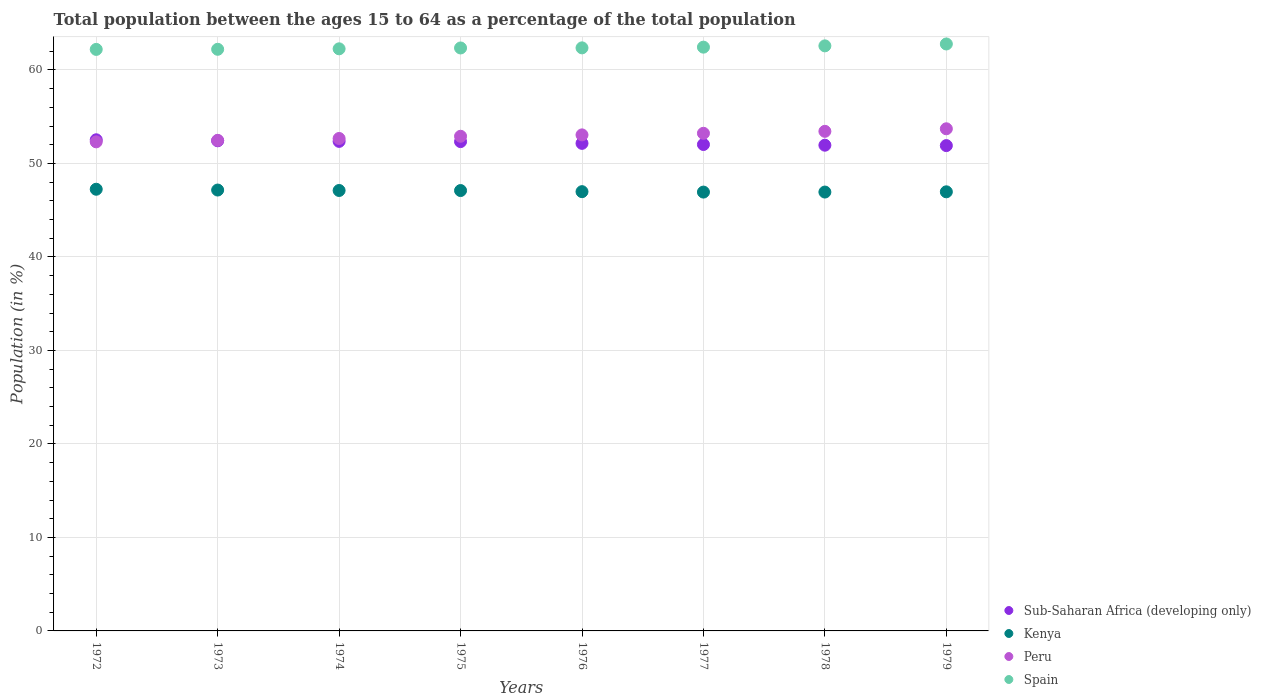What is the percentage of the population ages 15 to 64 in Sub-Saharan Africa (developing only) in 1975?
Keep it short and to the point. 52.34. Across all years, what is the maximum percentage of the population ages 15 to 64 in Kenya?
Your answer should be very brief. 47.24. Across all years, what is the minimum percentage of the population ages 15 to 64 in Peru?
Offer a terse response. 52.31. In which year was the percentage of the population ages 15 to 64 in Sub-Saharan Africa (developing only) minimum?
Your answer should be compact. 1979. What is the total percentage of the population ages 15 to 64 in Peru in the graph?
Keep it short and to the point. 423.77. What is the difference between the percentage of the population ages 15 to 64 in Kenya in 1974 and that in 1977?
Keep it short and to the point. 0.17. What is the difference between the percentage of the population ages 15 to 64 in Kenya in 1979 and the percentage of the population ages 15 to 64 in Spain in 1978?
Provide a short and direct response. -15.61. What is the average percentage of the population ages 15 to 64 in Spain per year?
Your answer should be compact. 62.4. In the year 1973, what is the difference between the percentage of the population ages 15 to 64 in Kenya and percentage of the population ages 15 to 64 in Spain?
Your response must be concise. -15.05. In how many years, is the percentage of the population ages 15 to 64 in Spain greater than 46?
Your response must be concise. 8. What is the ratio of the percentage of the population ages 15 to 64 in Kenya in 1973 to that in 1976?
Provide a short and direct response. 1. Is the difference between the percentage of the population ages 15 to 64 in Kenya in 1974 and 1978 greater than the difference between the percentage of the population ages 15 to 64 in Spain in 1974 and 1978?
Your answer should be very brief. Yes. What is the difference between the highest and the second highest percentage of the population ages 15 to 64 in Kenya?
Offer a terse response. 0.09. What is the difference between the highest and the lowest percentage of the population ages 15 to 64 in Sub-Saharan Africa (developing only)?
Your answer should be compact. 0.62. In how many years, is the percentage of the population ages 15 to 64 in Peru greater than the average percentage of the population ages 15 to 64 in Peru taken over all years?
Provide a short and direct response. 4. Is it the case that in every year, the sum of the percentage of the population ages 15 to 64 in Spain and percentage of the population ages 15 to 64 in Sub-Saharan Africa (developing only)  is greater than the percentage of the population ages 15 to 64 in Kenya?
Keep it short and to the point. Yes. What is the difference between two consecutive major ticks on the Y-axis?
Offer a terse response. 10. Are the values on the major ticks of Y-axis written in scientific E-notation?
Give a very brief answer. No. Does the graph contain any zero values?
Your answer should be very brief. No. Does the graph contain grids?
Ensure brevity in your answer.  Yes. Where does the legend appear in the graph?
Your answer should be compact. Bottom right. How are the legend labels stacked?
Your response must be concise. Vertical. What is the title of the graph?
Ensure brevity in your answer.  Total population between the ages 15 to 64 as a percentage of the total population. Does "Ghana" appear as one of the legend labels in the graph?
Keep it short and to the point. No. What is the Population (in %) in Sub-Saharan Africa (developing only) in 1972?
Provide a short and direct response. 52.53. What is the Population (in %) of Kenya in 1972?
Make the answer very short. 47.24. What is the Population (in %) in Peru in 1972?
Keep it short and to the point. 52.31. What is the Population (in %) in Spain in 1972?
Ensure brevity in your answer.  62.2. What is the Population (in %) in Sub-Saharan Africa (developing only) in 1973?
Your answer should be compact. 52.42. What is the Population (in %) of Kenya in 1973?
Your answer should be compact. 47.15. What is the Population (in %) of Peru in 1973?
Offer a terse response. 52.47. What is the Population (in %) of Spain in 1973?
Make the answer very short. 62.21. What is the Population (in %) in Sub-Saharan Africa (developing only) in 1974?
Give a very brief answer. 52.36. What is the Population (in %) in Kenya in 1974?
Keep it short and to the point. 47.11. What is the Population (in %) of Peru in 1974?
Give a very brief answer. 52.67. What is the Population (in %) in Spain in 1974?
Provide a short and direct response. 62.26. What is the Population (in %) of Sub-Saharan Africa (developing only) in 1975?
Offer a terse response. 52.34. What is the Population (in %) in Kenya in 1975?
Your answer should be very brief. 47.1. What is the Population (in %) of Peru in 1975?
Ensure brevity in your answer.  52.91. What is the Population (in %) of Spain in 1975?
Your response must be concise. 62.35. What is the Population (in %) of Sub-Saharan Africa (developing only) in 1976?
Offer a terse response. 52.15. What is the Population (in %) in Kenya in 1976?
Give a very brief answer. 46.98. What is the Population (in %) of Peru in 1976?
Your answer should be compact. 53.05. What is the Population (in %) in Spain in 1976?
Give a very brief answer. 62.36. What is the Population (in %) in Sub-Saharan Africa (developing only) in 1977?
Make the answer very short. 52.03. What is the Population (in %) of Kenya in 1977?
Your answer should be very brief. 46.94. What is the Population (in %) in Peru in 1977?
Provide a succinct answer. 53.22. What is the Population (in %) of Spain in 1977?
Provide a succinct answer. 62.44. What is the Population (in %) of Sub-Saharan Africa (developing only) in 1978?
Your answer should be very brief. 51.95. What is the Population (in %) in Kenya in 1978?
Provide a short and direct response. 46.94. What is the Population (in %) of Peru in 1978?
Provide a succinct answer. 53.43. What is the Population (in %) in Spain in 1978?
Give a very brief answer. 62.58. What is the Population (in %) of Sub-Saharan Africa (developing only) in 1979?
Give a very brief answer. 51.91. What is the Population (in %) in Kenya in 1979?
Provide a succinct answer. 46.97. What is the Population (in %) in Peru in 1979?
Offer a terse response. 53.71. What is the Population (in %) in Spain in 1979?
Give a very brief answer. 62.78. Across all years, what is the maximum Population (in %) of Sub-Saharan Africa (developing only)?
Ensure brevity in your answer.  52.53. Across all years, what is the maximum Population (in %) of Kenya?
Ensure brevity in your answer.  47.24. Across all years, what is the maximum Population (in %) in Peru?
Offer a terse response. 53.71. Across all years, what is the maximum Population (in %) of Spain?
Give a very brief answer. 62.78. Across all years, what is the minimum Population (in %) in Sub-Saharan Africa (developing only)?
Make the answer very short. 51.91. Across all years, what is the minimum Population (in %) in Kenya?
Ensure brevity in your answer.  46.94. Across all years, what is the minimum Population (in %) of Peru?
Provide a succinct answer. 52.31. Across all years, what is the minimum Population (in %) in Spain?
Your response must be concise. 62.2. What is the total Population (in %) in Sub-Saharan Africa (developing only) in the graph?
Your response must be concise. 417.68. What is the total Population (in %) of Kenya in the graph?
Your response must be concise. 376.42. What is the total Population (in %) in Peru in the graph?
Your response must be concise. 423.77. What is the total Population (in %) in Spain in the graph?
Provide a succinct answer. 499.17. What is the difference between the Population (in %) in Sub-Saharan Africa (developing only) in 1972 and that in 1973?
Provide a short and direct response. 0.11. What is the difference between the Population (in %) of Kenya in 1972 and that in 1973?
Offer a terse response. 0.09. What is the difference between the Population (in %) of Peru in 1972 and that in 1973?
Provide a short and direct response. -0.16. What is the difference between the Population (in %) in Spain in 1972 and that in 1973?
Provide a short and direct response. -0.01. What is the difference between the Population (in %) of Sub-Saharan Africa (developing only) in 1972 and that in 1974?
Offer a terse response. 0.17. What is the difference between the Population (in %) of Kenya in 1972 and that in 1974?
Keep it short and to the point. 0.13. What is the difference between the Population (in %) in Peru in 1972 and that in 1974?
Ensure brevity in your answer.  -0.36. What is the difference between the Population (in %) of Spain in 1972 and that in 1974?
Keep it short and to the point. -0.06. What is the difference between the Population (in %) of Sub-Saharan Africa (developing only) in 1972 and that in 1975?
Make the answer very short. 0.19. What is the difference between the Population (in %) of Kenya in 1972 and that in 1975?
Your response must be concise. 0.14. What is the difference between the Population (in %) in Peru in 1972 and that in 1975?
Ensure brevity in your answer.  -0.6. What is the difference between the Population (in %) of Spain in 1972 and that in 1975?
Offer a very short reply. -0.15. What is the difference between the Population (in %) in Sub-Saharan Africa (developing only) in 1972 and that in 1976?
Your answer should be very brief. 0.38. What is the difference between the Population (in %) of Kenya in 1972 and that in 1976?
Offer a terse response. 0.26. What is the difference between the Population (in %) in Peru in 1972 and that in 1976?
Ensure brevity in your answer.  -0.74. What is the difference between the Population (in %) of Spain in 1972 and that in 1976?
Your answer should be compact. -0.16. What is the difference between the Population (in %) of Sub-Saharan Africa (developing only) in 1972 and that in 1977?
Offer a terse response. 0.5. What is the difference between the Population (in %) of Kenya in 1972 and that in 1977?
Keep it short and to the point. 0.3. What is the difference between the Population (in %) of Peru in 1972 and that in 1977?
Your response must be concise. -0.92. What is the difference between the Population (in %) in Spain in 1972 and that in 1977?
Give a very brief answer. -0.24. What is the difference between the Population (in %) of Sub-Saharan Africa (developing only) in 1972 and that in 1978?
Keep it short and to the point. 0.58. What is the difference between the Population (in %) in Kenya in 1972 and that in 1978?
Keep it short and to the point. 0.3. What is the difference between the Population (in %) of Peru in 1972 and that in 1978?
Your answer should be very brief. -1.12. What is the difference between the Population (in %) in Spain in 1972 and that in 1978?
Your answer should be very brief. -0.38. What is the difference between the Population (in %) of Sub-Saharan Africa (developing only) in 1972 and that in 1979?
Ensure brevity in your answer.  0.62. What is the difference between the Population (in %) in Kenya in 1972 and that in 1979?
Your response must be concise. 0.27. What is the difference between the Population (in %) of Peru in 1972 and that in 1979?
Provide a short and direct response. -1.4. What is the difference between the Population (in %) in Spain in 1972 and that in 1979?
Offer a very short reply. -0.58. What is the difference between the Population (in %) in Sub-Saharan Africa (developing only) in 1973 and that in 1974?
Your answer should be compact. 0.06. What is the difference between the Population (in %) of Kenya in 1973 and that in 1974?
Make the answer very short. 0.05. What is the difference between the Population (in %) of Peru in 1973 and that in 1974?
Keep it short and to the point. -0.2. What is the difference between the Population (in %) in Spain in 1973 and that in 1974?
Ensure brevity in your answer.  -0.05. What is the difference between the Population (in %) of Sub-Saharan Africa (developing only) in 1973 and that in 1975?
Ensure brevity in your answer.  0.09. What is the difference between the Population (in %) in Kenya in 1973 and that in 1975?
Your answer should be compact. 0.05. What is the difference between the Population (in %) of Peru in 1973 and that in 1975?
Provide a short and direct response. -0.44. What is the difference between the Population (in %) in Spain in 1973 and that in 1975?
Ensure brevity in your answer.  -0.14. What is the difference between the Population (in %) in Sub-Saharan Africa (developing only) in 1973 and that in 1976?
Ensure brevity in your answer.  0.28. What is the difference between the Population (in %) of Kenya in 1973 and that in 1976?
Provide a short and direct response. 0.17. What is the difference between the Population (in %) of Peru in 1973 and that in 1976?
Give a very brief answer. -0.58. What is the difference between the Population (in %) in Spain in 1973 and that in 1976?
Provide a succinct answer. -0.15. What is the difference between the Population (in %) of Sub-Saharan Africa (developing only) in 1973 and that in 1977?
Your answer should be compact. 0.4. What is the difference between the Population (in %) of Kenya in 1973 and that in 1977?
Make the answer very short. 0.22. What is the difference between the Population (in %) of Peru in 1973 and that in 1977?
Give a very brief answer. -0.76. What is the difference between the Population (in %) in Spain in 1973 and that in 1977?
Provide a succinct answer. -0.23. What is the difference between the Population (in %) in Sub-Saharan Africa (developing only) in 1973 and that in 1978?
Your answer should be very brief. 0.47. What is the difference between the Population (in %) in Kenya in 1973 and that in 1978?
Keep it short and to the point. 0.22. What is the difference between the Population (in %) in Peru in 1973 and that in 1978?
Offer a very short reply. -0.96. What is the difference between the Population (in %) in Spain in 1973 and that in 1978?
Provide a succinct answer. -0.37. What is the difference between the Population (in %) of Sub-Saharan Africa (developing only) in 1973 and that in 1979?
Keep it short and to the point. 0.51. What is the difference between the Population (in %) of Kenya in 1973 and that in 1979?
Give a very brief answer. 0.19. What is the difference between the Population (in %) of Peru in 1973 and that in 1979?
Your response must be concise. -1.24. What is the difference between the Population (in %) in Spain in 1973 and that in 1979?
Your answer should be very brief. -0.57. What is the difference between the Population (in %) of Sub-Saharan Africa (developing only) in 1974 and that in 1975?
Provide a short and direct response. 0.02. What is the difference between the Population (in %) in Kenya in 1974 and that in 1975?
Offer a very short reply. 0.01. What is the difference between the Population (in %) of Peru in 1974 and that in 1975?
Make the answer very short. -0.24. What is the difference between the Population (in %) of Spain in 1974 and that in 1975?
Ensure brevity in your answer.  -0.09. What is the difference between the Population (in %) in Sub-Saharan Africa (developing only) in 1974 and that in 1976?
Make the answer very short. 0.21. What is the difference between the Population (in %) in Kenya in 1974 and that in 1976?
Offer a terse response. 0.13. What is the difference between the Population (in %) of Peru in 1974 and that in 1976?
Provide a succinct answer. -0.38. What is the difference between the Population (in %) in Spain in 1974 and that in 1976?
Make the answer very short. -0.1. What is the difference between the Population (in %) in Sub-Saharan Africa (developing only) in 1974 and that in 1977?
Keep it short and to the point. 0.33. What is the difference between the Population (in %) of Kenya in 1974 and that in 1977?
Provide a succinct answer. 0.17. What is the difference between the Population (in %) in Peru in 1974 and that in 1977?
Offer a very short reply. -0.55. What is the difference between the Population (in %) in Spain in 1974 and that in 1977?
Offer a terse response. -0.18. What is the difference between the Population (in %) of Sub-Saharan Africa (developing only) in 1974 and that in 1978?
Keep it short and to the point. 0.41. What is the difference between the Population (in %) in Kenya in 1974 and that in 1978?
Ensure brevity in your answer.  0.17. What is the difference between the Population (in %) of Peru in 1974 and that in 1978?
Keep it short and to the point. -0.76. What is the difference between the Population (in %) of Spain in 1974 and that in 1978?
Give a very brief answer. -0.32. What is the difference between the Population (in %) of Sub-Saharan Africa (developing only) in 1974 and that in 1979?
Your answer should be very brief. 0.45. What is the difference between the Population (in %) of Kenya in 1974 and that in 1979?
Your answer should be compact. 0.14. What is the difference between the Population (in %) of Peru in 1974 and that in 1979?
Provide a succinct answer. -1.04. What is the difference between the Population (in %) of Spain in 1974 and that in 1979?
Give a very brief answer. -0.52. What is the difference between the Population (in %) in Sub-Saharan Africa (developing only) in 1975 and that in 1976?
Offer a terse response. 0.19. What is the difference between the Population (in %) of Kenya in 1975 and that in 1976?
Offer a very short reply. 0.12. What is the difference between the Population (in %) in Peru in 1975 and that in 1976?
Your response must be concise. -0.15. What is the difference between the Population (in %) in Spain in 1975 and that in 1976?
Give a very brief answer. -0.01. What is the difference between the Population (in %) of Sub-Saharan Africa (developing only) in 1975 and that in 1977?
Your answer should be compact. 0.31. What is the difference between the Population (in %) of Kenya in 1975 and that in 1977?
Make the answer very short. 0.16. What is the difference between the Population (in %) of Peru in 1975 and that in 1977?
Your response must be concise. -0.32. What is the difference between the Population (in %) of Spain in 1975 and that in 1977?
Make the answer very short. -0.09. What is the difference between the Population (in %) of Sub-Saharan Africa (developing only) in 1975 and that in 1978?
Keep it short and to the point. 0.38. What is the difference between the Population (in %) of Kenya in 1975 and that in 1978?
Make the answer very short. 0.16. What is the difference between the Population (in %) of Peru in 1975 and that in 1978?
Provide a short and direct response. -0.53. What is the difference between the Population (in %) in Spain in 1975 and that in 1978?
Your answer should be compact. -0.23. What is the difference between the Population (in %) in Sub-Saharan Africa (developing only) in 1975 and that in 1979?
Keep it short and to the point. 0.43. What is the difference between the Population (in %) in Kenya in 1975 and that in 1979?
Your answer should be compact. 0.14. What is the difference between the Population (in %) in Peru in 1975 and that in 1979?
Your answer should be very brief. -0.8. What is the difference between the Population (in %) of Spain in 1975 and that in 1979?
Give a very brief answer. -0.43. What is the difference between the Population (in %) in Sub-Saharan Africa (developing only) in 1976 and that in 1977?
Offer a terse response. 0.12. What is the difference between the Population (in %) in Kenya in 1976 and that in 1977?
Offer a terse response. 0.05. What is the difference between the Population (in %) of Peru in 1976 and that in 1977?
Provide a succinct answer. -0.17. What is the difference between the Population (in %) of Spain in 1976 and that in 1977?
Provide a succinct answer. -0.08. What is the difference between the Population (in %) of Sub-Saharan Africa (developing only) in 1976 and that in 1978?
Keep it short and to the point. 0.2. What is the difference between the Population (in %) of Kenya in 1976 and that in 1978?
Your response must be concise. 0.04. What is the difference between the Population (in %) in Peru in 1976 and that in 1978?
Ensure brevity in your answer.  -0.38. What is the difference between the Population (in %) in Spain in 1976 and that in 1978?
Ensure brevity in your answer.  -0.21. What is the difference between the Population (in %) of Sub-Saharan Africa (developing only) in 1976 and that in 1979?
Your answer should be very brief. 0.24. What is the difference between the Population (in %) in Kenya in 1976 and that in 1979?
Provide a short and direct response. 0.02. What is the difference between the Population (in %) of Peru in 1976 and that in 1979?
Ensure brevity in your answer.  -0.65. What is the difference between the Population (in %) in Spain in 1976 and that in 1979?
Offer a very short reply. -0.42. What is the difference between the Population (in %) of Sub-Saharan Africa (developing only) in 1977 and that in 1978?
Ensure brevity in your answer.  0.07. What is the difference between the Population (in %) of Kenya in 1977 and that in 1978?
Offer a very short reply. -0. What is the difference between the Population (in %) of Peru in 1977 and that in 1978?
Provide a short and direct response. -0.21. What is the difference between the Population (in %) of Spain in 1977 and that in 1978?
Keep it short and to the point. -0.14. What is the difference between the Population (in %) in Sub-Saharan Africa (developing only) in 1977 and that in 1979?
Offer a terse response. 0.12. What is the difference between the Population (in %) in Kenya in 1977 and that in 1979?
Keep it short and to the point. -0.03. What is the difference between the Population (in %) of Peru in 1977 and that in 1979?
Give a very brief answer. -0.48. What is the difference between the Population (in %) in Spain in 1977 and that in 1979?
Ensure brevity in your answer.  -0.34. What is the difference between the Population (in %) of Sub-Saharan Africa (developing only) in 1978 and that in 1979?
Ensure brevity in your answer.  0.04. What is the difference between the Population (in %) of Kenya in 1978 and that in 1979?
Give a very brief answer. -0.03. What is the difference between the Population (in %) in Peru in 1978 and that in 1979?
Your response must be concise. -0.27. What is the difference between the Population (in %) in Spain in 1978 and that in 1979?
Your answer should be compact. -0.2. What is the difference between the Population (in %) in Sub-Saharan Africa (developing only) in 1972 and the Population (in %) in Kenya in 1973?
Give a very brief answer. 5.38. What is the difference between the Population (in %) in Sub-Saharan Africa (developing only) in 1972 and the Population (in %) in Peru in 1973?
Provide a short and direct response. 0.06. What is the difference between the Population (in %) of Sub-Saharan Africa (developing only) in 1972 and the Population (in %) of Spain in 1973?
Your answer should be very brief. -9.68. What is the difference between the Population (in %) of Kenya in 1972 and the Population (in %) of Peru in 1973?
Provide a succinct answer. -5.23. What is the difference between the Population (in %) of Kenya in 1972 and the Population (in %) of Spain in 1973?
Offer a very short reply. -14.97. What is the difference between the Population (in %) in Peru in 1972 and the Population (in %) in Spain in 1973?
Your response must be concise. -9.9. What is the difference between the Population (in %) in Sub-Saharan Africa (developing only) in 1972 and the Population (in %) in Kenya in 1974?
Make the answer very short. 5.42. What is the difference between the Population (in %) in Sub-Saharan Africa (developing only) in 1972 and the Population (in %) in Peru in 1974?
Your response must be concise. -0.14. What is the difference between the Population (in %) in Sub-Saharan Africa (developing only) in 1972 and the Population (in %) in Spain in 1974?
Provide a short and direct response. -9.73. What is the difference between the Population (in %) of Kenya in 1972 and the Population (in %) of Peru in 1974?
Make the answer very short. -5.43. What is the difference between the Population (in %) of Kenya in 1972 and the Population (in %) of Spain in 1974?
Your answer should be very brief. -15.02. What is the difference between the Population (in %) in Peru in 1972 and the Population (in %) in Spain in 1974?
Keep it short and to the point. -9.95. What is the difference between the Population (in %) of Sub-Saharan Africa (developing only) in 1972 and the Population (in %) of Kenya in 1975?
Your response must be concise. 5.43. What is the difference between the Population (in %) of Sub-Saharan Africa (developing only) in 1972 and the Population (in %) of Peru in 1975?
Offer a very short reply. -0.38. What is the difference between the Population (in %) of Sub-Saharan Africa (developing only) in 1972 and the Population (in %) of Spain in 1975?
Offer a very short reply. -9.82. What is the difference between the Population (in %) of Kenya in 1972 and the Population (in %) of Peru in 1975?
Make the answer very short. -5.67. What is the difference between the Population (in %) of Kenya in 1972 and the Population (in %) of Spain in 1975?
Keep it short and to the point. -15.11. What is the difference between the Population (in %) of Peru in 1972 and the Population (in %) of Spain in 1975?
Your answer should be compact. -10.04. What is the difference between the Population (in %) in Sub-Saharan Africa (developing only) in 1972 and the Population (in %) in Kenya in 1976?
Keep it short and to the point. 5.55. What is the difference between the Population (in %) of Sub-Saharan Africa (developing only) in 1972 and the Population (in %) of Peru in 1976?
Offer a very short reply. -0.52. What is the difference between the Population (in %) of Sub-Saharan Africa (developing only) in 1972 and the Population (in %) of Spain in 1976?
Offer a very short reply. -9.83. What is the difference between the Population (in %) of Kenya in 1972 and the Population (in %) of Peru in 1976?
Your answer should be very brief. -5.81. What is the difference between the Population (in %) in Kenya in 1972 and the Population (in %) in Spain in 1976?
Provide a succinct answer. -15.12. What is the difference between the Population (in %) in Peru in 1972 and the Population (in %) in Spain in 1976?
Give a very brief answer. -10.05. What is the difference between the Population (in %) of Sub-Saharan Africa (developing only) in 1972 and the Population (in %) of Kenya in 1977?
Ensure brevity in your answer.  5.59. What is the difference between the Population (in %) in Sub-Saharan Africa (developing only) in 1972 and the Population (in %) in Peru in 1977?
Offer a very short reply. -0.69. What is the difference between the Population (in %) of Sub-Saharan Africa (developing only) in 1972 and the Population (in %) of Spain in 1977?
Offer a terse response. -9.91. What is the difference between the Population (in %) of Kenya in 1972 and the Population (in %) of Peru in 1977?
Offer a very short reply. -5.99. What is the difference between the Population (in %) of Kenya in 1972 and the Population (in %) of Spain in 1977?
Make the answer very short. -15.2. What is the difference between the Population (in %) of Peru in 1972 and the Population (in %) of Spain in 1977?
Give a very brief answer. -10.13. What is the difference between the Population (in %) of Sub-Saharan Africa (developing only) in 1972 and the Population (in %) of Kenya in 1978?
Provide a short and direct response. 5.59. What is the difference between the Population (in %) of Sub-Saharan Africa (developing only) in 1972 and the Population (in %) of Peru in 1978?
Provide a short and direct response. -0.9. What is the difference between the Population (in %) in Sub-Saharan Africa (developing only) in 1972 and the Population (in %) in Spain in 1978?
Ensure brevity in your answer.  -10.05. What is the difference between the Population (in %) of Kenya in 1972 and the Population (in %) of Peru in 1978?
Give a very brief answer. -6.19. What is the difference between the Population (in %) of Kenya in 1972 and the Population (in %) of Spain in 1978?
Your response must be concise. -15.34. What is the difference between the Population (in %) in Peru in 1972 and the Population (in %) in Spain in 1978?
Offer a very short reply. -10.27. What is the difference between the Population (in %) of Sub-Saharan Africa (developing only) in 1972 and the Population (in %) of Kenya in 1979?
Provide a succinct answer. 5.56. What is the difference between the Population (in %) in Sub-Saharan Africa (developing only) in 1972 and the Population (in %) in Peru in 1979?
Your answer should be very brief. -1.18. What is the difference between the Population (in %) in Sub-Saharan Africa (developing only) in 1972 and the Population (in %) in Spain in 1979?
Give a very brief answer. -10.25. What is the difference between the Population (in %) in Kenya in 1972 and the Population (in %) in Peru in 1979?
Your answer should be very brief. -6.47. What is the difference between the Population (in %) in Kenya in 1972 and the Population (in %) in Spain in 1979?
Your response must be concise. -15.54. What is the difference between the Population (in %) in Peru in 1972 and the Population (in %) in Spain in 1979?
Offer a very short reply. -10.47. What is the difference between the Population (in %) of Sub-Saharan Africa (developing only) in 1973 and the Population (in %) of Kenya in 1974?
Your response must be concise. 5.31. What is the difference between the Population (in %) of Sub-Saharan Africa (developing only) in 1973 and the Population (in %) of Peru in 1974?
Provide a succinct answer. -0.25. What is the difference between the Population (in %) in Sub-Saharan Africa (developing only) in 1973 and the Population (in %) in Spain in 1974?
Your answer should be compact. -9.84. What is the difference between the Population (in %) in Kenya in 1973 and the Population (in %) in Peru in 1974?
Offer a terse response. -5.52. What is the difference between the Population (in %) in Kenya in 1973 and the Population (in %) in Spain in 1974?
Your answer should be compact. -15.11. What is the difference between the Population (in %) of Peru in 1973 and the Population (in %) of Spain in 1974?
Your answer should be very brief. -9.79. What is the difference between the Population (in %) in Sub-Saharan Africa (developing only) in 1973 and the Population (in %) in Kenya in 1975?
Provide a short and direct response. 5.32. What is the difference between the Population (in %) of Sub-Saharan Africa (developing only) in 1973 and the Population (in %) of Peru in 1975?
Your response must be concise. -0.48. What is the difference between the Population (in %) of Sub-Saharan Africa (developing only) in 1973 and the Population (in %) of Spain in 1975?
Give a very brief answer. -9.93. What is the difference between the Population (in %) in Kenya in 1973 and the Population (in %) in Peru in 1975?
Offer a terse response. -5.75. What is the difference between the Population (in %) in Kenya in 1973 and the Population (in %) in Spain in 1975?
Give a very brief answer. -15.2. What is the difference between the Population (in %) of Peru in 1973 and the Population (in %) of Spain in 1975?
Make the answer very short. -9.88. What is the difference between the Population (in %) in Sub-Saharan Africa (developing only) in 1973 and the Population (in %) in Kenya in 1976?
Give a very brief answer. 5.44. What is the difference between the Population (in %) in Sub-Saharan Africa (developing only) in 1973 and the Population (in %) in Peru in 1976?
Your response must be concise. -0.63. What is the difference between the Population (in %) in Sub-Saharan Africa (developing only) in 1973 and the Population (in %) in Spain in 1976?
Offer a very short reply. -9.94. What is the difference between the Population (in %) of Kenya in 1973 and the Population (in %) of Peru in 1976?
Offer a terse response. -5.9. What is the difference between the Population (in %) of Kenya in 1973 and the Population (in %) of Spain in 1976?
Keep it short and to the point. -15.21. What is the difference between the Population (in %) of Peru in 1973 and the Population (in %) of Spain in 1976?
Your answer should be very brief. -9.89. What is the difference between the Population (in %) in Sub-Saharan Africa (developing only) in 1973 and the Population (in %) in Kenya in 1977?
Your response must be concise. 5.49. What is the difference between the Population (in %) in Sub-Saharan Africa (developing only) in 1973 and the Population (in %) in Peru in 1977?
Offer a very short reply. -0.8. What is the difference between the Population (in %) of Sub-Saharan Africa (developing only) in 1973 and the Population (in %) of Spain in 1977?
Offer a terse response. -10.02. What is the difference between the Population (in %) in Kenya in 1973 and the Population (in %) in Peru in 1977?
Your answer should be very brief. -6.07. What is the difference between the Population (in %) in Kenya in 1973 and the Population (in %) in Spain in 1977?
Provide a succinct answer. -15.28. What is the difference between the Population (in %) in Peru in 1973 and the Population (in %) in Spain in 1977?
Offer a very short reply. -9.97. What is the difference between the Population (in %) of Sub-Saharan Africa (developing only) in 1973 and the Population (in %) of Kenya in 1978?
Your answer should be compact. 5.48. What is the difference between the Population (in %) of Sub-Saharan Africa (developing only) in 1973 and the Population (in %) of Peru in 1978?
Ensure brevity in your answer.  -1.01. What is the difference between the Population (in %) of Sub-Saharan Africa (developing only) in 1973 and the Population (in %) of Spain in 1978?
Offer a very short reply. -10.15. What is the difference between the Population (in %) of Kenya in 1973 and the Population (in %) of Peru in 1978?
Offer a very short reply. -6.28. What is the difference between the Population (in %) of Kenya in 1973 and the Population (in %) of Spain in 1978?
Your response must be concise. -15.42. What is the difference between the Population (in %) of Peru in 1973 and the Population (in %) of Spain in 1978?
Provide a succinct answer. -10.11. What is the difference between the Population (in %) of Sub-Saharan Africa (developing only) in 1973 and the Population (in %) of Kenya in 1979?
Offer a terse response. 5.46. What is the difference between the Population (in %) in Sub-Saharan Africa (developing only) in 1973 and the Population (in %) in Peru in 1979?
Keep it short and to the point. -1.28. What is the difference between the Population (in %) in Sub-Saharan Africa (developing only) in 1973 and the Population (in %) in Spain in 1979?
Keep it short and to the point. -10.35. What is the difference between the Population (in %) in Kenya in 1973 and the Population (in %) in Peru in 1979?
Offer a terse response. -6.55. What is the difference between the Population (in %) in Kenya in 1973 and the Population (in %) in Spain in 1979?
Give a very brief answer. -15.62. What is the difference between the Population (in %) of Peru in 1973 and the Population (in %) of Spain in 1979?
Keep it short and to the point. -10.31. What is the difference between the Population (in %) of Sub-Saharan Africa (developing only) in 1974 and the Population (in %) of Kenya in 1975?
Keep it short and to the point. 5.26. What is the difference between the Population (in %) in Sub-Saharan Africa (developing only) in 1974 and the Population (in %) in Peru in 1975?
Your response must be concise. -0.55. What is the difference between the Population (in %) in Sub-Saharan Africa (developing only) in 1974 and the Population (in %) in Spain in 1975?
Ensure brevity in your answer.  -9.99. What is the difference between the Population (in %) of Kenya in 1974 and the Population (in %) of Peru in 1975?
Your answer should be very brief. -5.8. What is the difference between the Population (in %) in Kenya in 1974 and the Population (in %) in Spain in 1975?
Provide a short and direct response. -15.24. What is the difference between the Population (in %) of Peru in 1974 and the Population (in %) of Spain in 1975?
Your answer should be compact. -9.68. What is the difference between the Population (in %) in Sub-Saharan Africa (developing only) in 1974 and the Population (in %) in Kenya in 1976?
Offer a very short reply. 5.38. What is the difference between the Population (in %) of Sub-Saharan Africa (developing only) in 1974 and the Population (in %) of Peru in 1976?
Your response must be concise. -0.69. What is the difference between the Population (in %) in Sub-Saharan Africa (developing only) in 1974 and the Population (in %) in Spain in 1976?
Keep it short and to the point. -10. What is the difference between the Population (in %) in Kenya in 1974 and the Population (in %) in Peru in 1976?
Your response must be concise. -5.95. What is the difference between the Population (in %) of Kenya in 1974 and the Population (in %) of Spain in 1976?
Keep it short and to the point. -15.25. What is the difference between the Population (in %) in Peru in 1974 and the Population (in %) in Spain in 1976?
Ensure brevity in your answer.  -9.69. What is the difference between the Population (in %) in Sub-Saharan Africa (developing only) in 1974 and the Population (in %) in Kenya in 1977?
Keep it short and to the point. 5.42. What is the difference between the Population (in %) in Sub-Saharan Africa (developing only) in 1974 and the Population (in %) in Peru in 1977?
Offer a very short reply. -0.87. What is the difference between the Population (in %) of Sub-Saharan Africa (developing only) in 1974 and the Population (in %) of Spain in 1977?
Your answer should be compact. -10.08. What is the difference between the Population (in %) in Kenya in 1974 and the Population (in %) in Peru in 1977?
Your response must be concise. -6.12. What is the difference between the Population (in %) of Kenya in 1974 and the Population (in %) of Spain in 1977?
Make the answer very short. -15.33. What is the difference between the Population (in %) of Peru in 1974 and the Population (in %) of Spain in 1977?
Give a very brief answer. -9.77. What is the difference between the Population (in %) in Sub-Saharan Africa (developing only) in 1974 and the Population (in %) in Kenya in 1978?
Offer a terse response. 5.42. What is the difference between the Population (in %) in Sub-Saharan Africa (developing only) in 1974 and the Population (in %) in Peru in 1978?
Provide a short and direct response. -1.07. What is the difference between the Population (in %) of Sub-Saharan Africa (developing only) in 1974 and the Population (in %) of Spain in 1978?
Your answer should be very brief. -10.22. What is the difference between the Population (in %) of Kenya in 1974 and the Population (in %) of Peru in 1978?
Your answer should be very brief. -6.33. What is the difference between the Population (in %) in Kenya in 1974 and the Population (in %) in Spain in 1978?
Provide a succinct answer. -15.47. What is the difference between the Population (in %) of Peru in 1974 and the Population (in %) of Spain in 1978?
Provide a short and direct response. -9.91. What is the difference between the Population (in %) in Sub-Saharan Africa (developing only) in 1974 and the Population (in %) in Kenya in 1979?
Your answer should be very brief. 5.39. What is the difference between the Population (in %) of Sub-Saharan Africa (developing only) in 1974 and the Population (in %) of Peru in 1979?
Offer a terse response. -1.35. What is the difference between the Population (in %) of Sub-Saharan Africa (developing only) in 1974 and the Population (in %) of Spain in 1979?
Offer a terse response. -10.42. What is the difference between the Population (in %) of Kenya in 1974 and the Population (in %) of Peru in 1979?
Your answer should be very brief. -6.6. What is the difference between the Population (in %) of Kenya in 1974 and the Population (in %) of Spain in 1979?
Ensure brevity in your answer.  -15.67. What is the difference between the Population (in %) in Peru in 1974 and the Population (in %) in Spain in 1979?
Offer a very short reply. -10.11. What is the difference between the Population (in %) of Sub-Saharan Africa (developing only) in 1975 and the Population (in %) of Kenya in 1976?
Give a very brief answer. 5.35. What is the difference between the Population (in %) in Sub-Saharan Africa (developing only) in 1975 and the Population (in %) in Peru in 1976?
Make the answer very short. -0.72. What is the difference between the Population (in %) of Sub-Saharan Africa (developing only) in 1975 and the Population (in %) of Spain in 1976?
Keep it short and to the point. -10.03. What is the difference between the Population (in %) of Kenya in 1975 and the Population (in %) of Peru in 1976?
Your answer should be very brief. -5.95. What is the difference between the Population (in %) of Kenya in 1975 and the Population (in %) of Spain in 1976?
Provide a succinct answer. -15.26. What is the difference between the Population (in %) in Peru in 1975 and the Population (in %) in Spain in 1976?
Offer a terse response. -9.46. What is the difference between the Population (in %) of Sub-Saharan Africa (developing only) in 1975 and the Population (in %) of Kenya in 1977?
Ensure brevity in your answer.  5.4. What is the difference between the Population (in %) in Sub-Saharan Africa (developing only) in 1975 and the Population (in %) in Peru in 1977?
Your answer should be compact. -0.89. What is the difference between the Population (in %) of Sub-Saharan Africa (developing only) in 1975 and the Population (in %) of Spain in 1977?
Your answer should be compact. -10.1. What is the difference between the Population (in %) of Kenya in 1975 and the Population (in %) of Peru in 1977?
Offer a terse response. -6.12. What is the difference between the Population (in %) in Kenya in 1975 and the Population (in %) in Spain in 1977?
Provide a short and direct response. -15.34. What is the difference between the Population (in %) in Peru in 1975 and the Population (in %) in Spain in 1977?
Give a very brief answer. -9.53. What is the difference between the Population (in %) of Sub-Saharan Africa (developing only) in 1975 and the Population (in %) of Kenya in 1978?
Keep it short and to the point. 5.4. What is the difference between the Population (in %) of Sub-Saharan Africa (developing only) in 1975 and the Population (in %) of Peru in 1978?
Provide a short and direct response. -1.1. What is the difference between the Population (in %) of Sub-Saharan Africa (developing only) in 1975 and the Population (in %) of Spain in 1978?
Offer a very short reply. -10.24. What is the difference between the Population (in %) of Kenya in 1975 and the Population (in %) of Peru in 1978?
Offer a very short reply. -6.33. What is the difference between the Population (in %) of Kenya in 1975 and the Population (in %) of Spain in 1978?
Provide a short and direct response. -15.48. What is the difference between the Population (in %) of Peru in 1975 and the Population (in %) of Spain in 1978?
Your answer should be compact. -9.67. What is the difference between the Population (in %) in Sub-Saharan Africa (developing only) in 1975 and the Population (in %) in Kenya in 1979?
Offer a terse response. 5.37. What is the difference between the Population (in %) in Sub-Saharan Africa (developing only) in 1975 and the Population (in %) in Peru in 1979?
Provide a succinct answer. -1.37. What is the difference between the Population (in %) in Sub-Saharan Africa (developing only) in 1975 and the Population (in %) in Spain in 1979?
Your response must be concise. -10.44. What is the difference between the Population (in %) of Kenya in 1975 and the Population (in %) of Peru in 1979?
Offer a very short reply. -6.61. What is the difference between the Population (in %) of Kenya in 1975 and the Population (in %) of Spain in 1979?
Offer a terse response. -15.68. What is the difference between the Population (in %) of Peru in 1975 and the Population (in %) of Spain in 1979?
Keep it short and to the point. -9.87. What is the difference between the Population (in %) in Sub-Saharan Africa (developing only) in 1976 and the Population (in %) in Kenya in 1977?
Offer a terse response. 5.21. What is the difference between the Population (in %) of Sub-Saharan Africa (developing only) in 1976 and the Population (in %) of Peru in 1977?
Your answer should be very brief. -1.08. What is the difference between the Population (in %) in Sub-Saharan Africa (developing only) in 1976 and the Population (in %) in Spain in 1977?
Ensure brevity in your answer.  -10.29. What is the difference between the Population (in %) of Kenya in 1976 and the Population (in %) of Peru in 1977?
Provide a short and direct response. -6.24. What is the difference between the Population (in %) in Kenya in 1976 and the Population (in %) in Spain in 1977?
Your response must be concise. -15.46. What is the difference between the Population (in %) of Peru in 1976 and the Population (in %) of Spain in 1977?
Make the answer very short. -9.38. What is the difference between the Population (in %) in Sub-Saharan Africa (developing only) in 1976 and the Population (in %) in Kenya in 1978?
Your answer should be compact. 5.21. What is the difference between the Population (in %) of Sub-Saharan Africa (developing only) in 1976 and the Population (in %) of Peru in 1978?
Give a very brief answer. -1.29. What is the difference between the Population (in %) in Sub-Saharan Africa (developing only) in 1976 and the Population (in %) in Spain in 1978?
Keep it short and to the point. -10.43. What is the difference between the Population (in %) in Kenya in 1976 and the Population (in %) in Peru in 1978?
Offer a very short reply. -6.45. What is the difference between the Population (in %) in Kenya in 1976 and the Population (in %) in Spain in 1978?
Provide a succinct answer. -15.59. What is the difference between the Population (in %) of Peru in 1976 and the Population (in %) of Spain in 1978?
Give a very brief answer. -9.52. What is the difference between the Population (in %) in Sub-Saharan Africa (developing only) in 1976 and the Population (in %) in Kenya in 1979?
Ensure brevity in your answer.  5.18. What is the difference between the Population (in %) of Sub-Saharan Africa (developing only) in 1976 and the Population (in %) of Peru in 1979?
Provide a succinct answer. -1.56. What is the difference between the Population (in %) in Sub-Saharan Africa (developing only) in 1976 and the Population (in %) in Spain in 1979?
Provide a short and direct response. -10.63. What is the difference between the Population (in %) in Kenya in 1976 and the Population (in %) in Peru in 1979?
Provide a succinct answer. -6.73. What is the difference between the Population (in %) in Kenya in 1976 and the Population (in %) in Spain in 1979?
Your answer should be very brief. -15.8. What is the difference between the Population (in %) in Peru in 1976 and the Population (in %) in Spain in 1979?
Offer a very short reply. -9.72. What is the difference between the Population (in %) in Sub-Saharan Africa (developing only) in 1977 and the Population (in %) in Kenya in 1978?
Give a very brief answer. 5.09. What is the difference between the Population (in %) in Sub-Saharan Africa (developing only) in 1977 and the Population (in %) in Peru in 1978?
Your answer should be compact. -1.41. What is the difference between the Population (in %) of Sub-Saharan Africa (developing only) in 1977 and the Population (in %) of Spain in 1978?
Your answer should be very brief. -10.55. What is the difference between the Population (in %) in Kenya in 1977 and the Population (in %) in Peru in 1978?
Give a very brief answer. -6.5. What is the difference between the Population (in %) of Kenya in 1977 and the Population (in %) of Spain in 1978?
Your response must be concise. -15.64. What is the difference between the Population (in %) in Peru in 1977 and the Population (in %) in Spain in 1978?
Provide a short and direct response. -9.35. What is the difference between the Population (in %) of Sub-Saharan Africa (developing only) in 1977 and the Population (in %) of Kenya in 1979?
Offer a terse response. 5.06. What is the difference between the Population (in %) of Sub-Saharan Africa (developing only) in 1977 and the Population (in %) of Peru in 1979?
Provide a short and direct response. -1.68. What is the difference between the Population (in %) of Sub-Saharan Africa (developing only) in 1977 and the Population (in %) of Spain in 1979?
Provide a short and direct response. -10.75. What is the difference between the Population (in %) in Kenya in 1977 and the Population (in %) in Peru in 1979?
Your answer should be very brief. -6.77. What is the difference between the Population (in %) in Kenya in 1977 and the Population (in %) in Spain in 1979?
Your answer should be very brief. -15.84. What is the difference between the Population (in %) of Peru in 1977 and the Population (in %) of Spain in 1979?
Keep it short and to the point. -9.55. What is the difference between the Population (in %) of Sub-Saharan Africa (developing only) in 1978 and the Population (in %) of Kenya in 1979?
Provide a short and direct response. 4.99. What is the difference between the Population (in %) in Sub-Saharan Africa (developing only) in 1978 and the Population (in %) in Peru in 1979?
Offer a terse response. -1.76. What is the difference between the Population (in %) of Sub-Saharan Africa (developing only) in 1978 and the Population (in %) of Spain in 1979?
Your response must be concise. -10.83. What is the difference between the Population (in %) in Kenya in 1978 and the Population (in %) in Peru in 1979?
Offer a very short reply. -6.77. What is the difference between the Population (in %) in Kenya in 1978 and the Population (in %) in Spain in 1979?
Your response must be concise. -15.84. What is the difference between the Population (in %) of Peru in 1978 and the Population (in %) of Spain in 1979?
Provide a succinct answer. -9.34. What is the average Population (in %) of Sub-Saharan Africa (developing only) per year?
Provide a succinct answer. 52.21. What is the average Population (in %) of Kenya per year?
Your answer should be compact. 47.05. What is the average Population (in %) of Peru per year?
Your answer should be compact. 52.97. What is the average Population (in %) in Spain per year?
Provide a succinct answer. 62.4. In the year 1972, what is the difference between the Population (in %) of Sub-Saharan Africa (developing only) and Population (in %) of Kenya?
Your response must be concise. 5.29. In the year 1972, what is the difference between the Population (in %) in Sub-Saharan Africa (developing only) and Population (in %) in Peru?
Make the answer very short. 0.22. In the year 1972, what is the difference between the Population (in %) of Sub-Saharan Africa (developing only) and Population (in %) of Spain?
Offer a terse response. -9.67. In the year 1972, what is the difference between the Population (in %) in Kenya and Population (in %) in Peru?
Provide a succinct answer. -5.07. In the year 1972, what is the difference between the Population (in %) in Kenya and Population (in %) in Spain?
Make the answer very short. -14.96. In the year 1972, what is the difference between the Population (in %) in Peru and Population (in %) in Spain?
Your response must be concise. -9.89. In the year 1973, what is the difference between the Population (in %) of Sub-Saharan Africa (developing only) and Population (in %) of Kenya?
Offer a terse response. 5.27. In the year 1973, what is the difference between the Population (in %) of Sub-Saharan Africa (developing only) and Population (in %) of Peru?
Provide a succinct answer. -0.05. In the year 1973, what is the difference between the Population (in %) of Sub-Saharan Africa (developing only) and Population (in %) of Spain?
Ensure brevity in your answer.  -9.79. In the year 1973, what is the difference between the Population (in %) in Kenya and Population (in %) in Peru?
Keep it short and to the point. -5.31. In the year 1973, what is the difference between the Population (in %) in Kenya and Population (in %) in Spain?
Ensure brevity in your answer.  -15.05. In the year 1973, what is the difference between the Population (in %) of Peru and Population (in %) of Spain?
Provide a succinct answer. -9.74. In the year 1974, what is the difference between the Population (in %) of Sub-Saharan Africa (developing only) and Population (in %) of Kenya?
Provide a succinct answer. 5.25. In the year 1974, what is the difference between the Population (in %) of Sub-Saharan Africa (developing only) and Population (in %) of Peru?
Ensure brevity in your answer.  -0.31. In the year 1974, what is the difference between the Population (in %) in Sub-Saharan Africa (developing only) and Population (in %) in Spain?
Provide a succinct answer. -9.9. In the year 1974, what is the difference between the Population (in %) in Kenya and Population (in %) in Peru?
Offer a terse response. -5.56. In the year 1974, what is the difference between the Population (in %) in Kenya and Population (in %) in Spain?
Your answer should be very brief. -15.15. In the year 1974, what is the difference between the Population (in %) of Peru and Population (in %) of Spain?
Your response must be concise. -9.59. In the year 1975, what is the difference between the Population (in %) in Sub-Saharan Africa (developing only) and Population (in %) in Kenya?
Give a very brief answer. 5.23. In the year 1975, what is the difference between the Population (in %) of Sub-Saharan Africa (developing only) and Population (in %) of Peru?
Your response must be concise. -0.57. In the year 1975, what is the difference between the Population (in %) of Sub-Saharan Africa (developing only) and Population (in %) of Spain?
Make the answer very short. -10.02. In the year 1975, what is the difference between the Population (in %) of Kenya and Population (in %) of Peru?
Your answer should be very brief. -5.81. In the year 1975, what is the difference between the Population (in %) of Kenya and Population (in %) of Spain?
Ensure brevity in your answer.  -15.25. In the year 1975, what is the difference between the Population (in %) in Peru and Population (in %) in Spain?
Your answer should be very brief. -9.44. In the year 1976, what is the difference between the Population (in %) of Sub-Saharan Africa (developing only) and Population (in %) of Kenya?
Your answer should be compact. 5.17. In the year 1976, what is the difference between the Population (in %) in Sub-Saharan Africa (developing only) and Population (in %) in Peru?
Provide a short and direct response. -0.91. In the year 1976, what is the difference between the Population (in %) in Sub-Saharan Africa (developing only) and Population (in %) in Spain?
Ensure brevity in your answer.  -10.21. In the year 1976, what is the difference between the Population (in %) of Kenya and Population (in %) of Peru?
Provide a short and direct response. -6.07. In the year 1976, what is the difference between the Population (in %) in Kenya and Population (in %) in Spain?
Keep it short and to the point. -15.38. In the year 1976, what is the difference between the Population (in %) of Peru and Population (in %) of Spain?
Give a very brief answer. -9.31. In the year 1977, what is the difference between the Population (in %) in Sub-Saharan Africa (developing only) and Population (in %) in Kenya?
Make the answer very short. 5.09. In the year 1977, what is the difference between the Population (in %) of Sub-Saharan Africa (developing only) and Population (in %) of Peru?
Ensure brevity in your answer.  -1.2. In the year 1977, what is the difference between the Population (in %) in Sub-Saharan Africa (developing only) and Population (in %) in Spain?
Your answer should be compact. -10.41. In the year 1977, what is the difference between the Population (in %) in Kenya and Population (in %) in Peru?
Your answer should be very brief. -6.29. In the year 1977, what is the difference between the Population (in %) in Kenya and Population (in %) in Spain?
Your answer should be compact. -15.5. In the year 1977, what is the difference between the Population (in %) of Peru and Population (in %) of Spain?
Make the answer very short. -9.21. In the year 1978, what is the difference between the Population (in %) in Sub-Saharan Africa (developing only) and Population (in %) in Kenya?
Your response must be concise. 5.01. In the year 1978, what is the difference between the Population (in %) of Sub-Saharan Africa (developing only) and Population (in %) of Peru?
Offer a terse response. -1.48. In the year 1978, what is the difference between the Population (in %) in Sub-Saharan Africa (developing only) and Population (in %) in Spain?
Ensure brevity in your answer.  -10.62. In the year 1978, what is the difference between the Population (in %) of Kenya and Population (in %) of Peru?
Give a very brief answer. -6.49. In the year 1978, what is the difference between the Population (in %) of Kenya and Population (in %) of Spain?
Keep it short and to the point. -15.64. In the year 1978, what is the difference between the Population (in %) in Peru and Population (in %) in Spain?
Ensure brevity in your answer.  -9.14. In the year 1979, what is the difference between the Population (in %) of Sub-Saharan Africa (developing only) and Population (in %) of Kenya?
Make the answer very short. 4.94. In the year 1979, what is the difference between the Population (in %) in Sub-Saharan Africa (developing only) and Population (in %) in Peru?
Your response must be concise. -1.8. In the year 1979, what is the difference between the Population (in %) of Sub-Saharan Africa (developing only) and Population (in %) of Spain?
Your response must be concise. -10.87. In the year 1979, what is the difference between the Population (in %) of Kenya and Population (in %) of Peru?
Offer a very short reply. -6.74. In the year 1979, what is the difference between the Population (in %) of Kenya and Population (in %) of Spain?
Give a very brief answer. -15.81. In the year 1979, what is the difference between the Population (in %) of Peru and Population (in %) of Spain?
Provide a short and direct response. -9.07. What is the ratio of the Population (in %) in Spain in 1972 to that in 1973?
Offer a very short reply. 1. What is the ratio of the Population (in %) of Sub-Saharan Africa (developing only) in 1972 to that in 1974?
Offer a terse response. 1. What is the ratio of the Population (in %) in Kenya in 1972 to that in 1974?
Provide a short and direct response. 1. What is the ratio of the Population (in %) of Sub-Saharan Africa (developing only) in 1972 to that in 1975?
Your response must be concise. 1. What is the ratio of the Population (in %) of Peru in 1972 to that in 1975?
Keep it short and to the point. 0.99. What is the ratio of the Population (in %) in Sub-Saharan Africa (developing only) in 1972 to that in 1976?
Offer a terse response. 1.01. What is the ratio of the Population (in %) in Kenya in 1972 to that in 1976?
Give a very brief answer. 1.01. What is the ratio of the Population (in %) in Peru in 1972 to that in 1976?
Provide a succinct answer. 0.99. What is the ratio of the Population (in %) of Spain in 1972 to that in 1976?
Ensure brevity in your answer.  1. What is the ratio of the Population (in %) in Sub-Saharan Africa (developing only) in 1972 to that in 1977?
Offer a terse response. 1.01. What is the ratio of the Population (in %) of Kenya in 1972 to that in 1977?
Your answer should be compact. 1.01. What is the ratio of the Population (in %) in Peru in 1972 to that in 1977?
Your answer should be very brief. 0.98. What is the ratio of the Population (in %) of Spain in 1972 to that in 1977?
Your response must be concise. 1. What is the ratio of the Population (in %) in Sub-Saharan Africa (developing only) in 1972 to that in 1978?
Offer a terse response. 1.01. What is the ratio of the Population (in %) of Kenya in 1972 to that in 1978?
Give a very brief answer. 1.01. What is the ratio of the Population (in %) of Spain in 1972 to that in 1978?
Give a very brief answer. 0.99. What is the ratio of the Population (in %) of Peru in 1972 to that in 1979?
Your answer should be very brief. 0.97. What is the ratio of the Population (in %) of Kenya in 1973 to that in 1974?
Make the answer very short. 1. What is the ratio of the Population (in %) in Spain in 1973 to that in 1974?
Offer a terse response. 1. What is the ratio of the Population (in %) of Sub-Saharan Africa (developing only) in 1973 to that in 1975?
Offer a terse response. 1. What is the ratio of the Population (in %) of Kenya in 1973 to that in 1975?
Provide a short and direct response. 1. What is the ratio of the Population (in %) of Spain in 1973 to that in 1975?
Provide a succinct answer. 1. What is the ratio of the Population (in %) in Peru in 1973 to that in 1976?
Ensure brevity in your answer.  0.99. What is the ratio of the Population (in %) of Spain in 1973 to that in 1976?
Your answer should be very brief. 1. What is the ratio of the Population (in %) of Sub-Saharan Africa (developing only) in 1973 to that in 1977?
Offer a very short reply. 1.01. What is the ratio of the Population (in %) in Kenya in 1973 to that in 1977?
Provide a short and direct response. 1. What is the ratio of the Population (in %) in Peru in 1973 to that in 1977?
Keep it short and to the point. 0.99. What is the ratio of the Population (in %) of Spain in 1973 to that in 1977?
Provide a succinct answer. 1. What is the ratio of the Population (in %) of Sub-Saharan Africa (developing only) in 1973 to that in 1978?
Your answer should be compact. 1.01. What is the ratio of the Population (in %) in Kenya in 1973 to that in 1978?
Your answer should be compact. 1. What is the ratio of the Population (in %) in Peru in 1973 to that in 1978?
Provide a succinct answer. 0.98. What is the ratio of the Population (in %) in Sub-Saharan Africa (developing only) in 1973 to that in 1979?
Offer a very short reply. 1.01. What is the ratio of the Population (in %) of Spain in 1973 to that in 1979?
Offer a terse response. 0.99. What is the ratio of the Population (in %) of Sub-Saharan Africa (developing only) in 1974 to that in 1975?
Give a very brief answer. 1. What is the ratio of the Population (in %) of Peru in 1974 to that in 1975?
Your answer should be compact. 1. What is the ratio of the Population (in %) in Sub-Saharan Africa (developing only) in 1974 to that in 1976?
Keep it short and to the point. 1. What is the ratio of the Population (in %) of Kenya in 1974 to that in 1976?
Ensure brevity in your answer.  1. What is the ratio of the Population (in %) in Sub-Saharan Africa (developing only) in 1974 to that in 1977?
Provide a short and direct response. 1.01. What is the ratio of the Population (in %) of Peru in 1974 to that in 1977?
Offer a very short reply. 0.99. What is the ratio of the Population (in %) in Spain in 1974 to that in 1977?
Your answer should be very brief. 1. What is the ratio of the Population (in %) of Sub-Saharan Africa (developing only) in 1974 to that in 1978?
Ensure brevity in your answer.  1.01. What is the ratio of the Population (in %) in Kenya in 1974 to that in 1978?
Offer a terse response. 1. What is the ratio of the Population (in %) of Peru in 1974 to that in 1978?
Give a very brief answer. 0.99. What is the ratio of the Population (in %) of Sub-Saharan Africa (developing only) in 1974 to that in 1979?
Provide a short and direct response. 1.01. What is the ratio of the Population (in %) in Peru in 1974 to that in 1979?
Provide a succinct answer. 0.98. What is the ratio of the Population (in %) of Sub-Saharan Africa (developing only) in 1975 to that in 1976?
Provide a succinct answer. 1. What is the ratio of the Population (in %) in Peru in 1975 to that in 1976?
Your response must be concise. 1. What is the ratio of the Population (in %) in Spain in 1975 to that in 1976?
Offer a very short reply. 1. What is the ratio of the Population (in %) in Sub-Saharan Africa (developing only) in 1975 to that in 1978?
Keep it short and to the point. 1.01. What is the ratio of the Population (in %) in Peru in 1975 to that in 1978?
Your answer should be compact. 0.99. What is the ratio of the Population (in %) of Sub-Saharan Africa (developing only) in 1975 to that in 1979?
Ensure brevity in your answer.  1.01. What is the ratio of the Population (in %) in Kenya in 1975 to that in 1979?
Provide a succinct answer. 1. What is the ratio of the Population (in %) in Peru in 1975 to that in 1979?
Your answer should be compact. 0.99. What is the ratio of the Population (in %) in Spain in 1975 to that in 1979?
Your answer should be very brief. 0.99. What is the ratio of the Population (in %) in Sub-Saharan Africa (developing only) in 1976 to that in 1977?
Offer a terse response. 1. What is the ratio of the Population (in %) of Peru in 1976 to that in 1979?
Your answer should be very brief. 0.99. What is the ratio of the Population (in %) of Spain in 1976 to that in 1979?
Provide a succinct answer. 0.99. What is the ratio of the Population (in %) in Sub-Saharan Africa (developing only) in 1977 to that in 1978?
Ensure brevity in your answer.  1. What is the ratio of the Population (in %) of Spain in 1977 to that in 1978?
Your response must be concise. 1. What is the ratio of the Population (in %) in Peru in 1977 to that in 1979?
Offer a terse response. 0.99. What is the ratio of the Population (in %) in Spain in 1977 to that in 1979?
Offer a terse response. 0.99. What is the ratio of the Population (in %) in Sub-Saharan Africa (developing only) in 1978 to that in 1979?
Your answer should be very brief. 1. What is the ratio of the Population (in %) of Kenya in 1978 to that in 1979?
Your response must be concise. 1. What is the difference between the highest and the second highest Population (in %) of Sub-Saharan Africa (developing only)?
Provide a short and direct response. 0.11. What is the difference between the highest and the second highest Population (in %) of Kenya?
Give a very brief answer. 0.09. What is the difference between the highest and the second highest Population (in %) in Peru?
Your response must be concise. 0.27. What is the difference between the highest and the second highest Population (in %) of Spain?
Make the answer very short. 0.2. What is the difference between the highest and the lowest Population (in %) of Sub-Saharan Africa (developing only)?
Your answer should be very brief. 0.62. What is the difference between the highest and the lowest Population (in %) of Kenya?
Ensure brevity in your answer.  0.3. What is the difference between the highest and the lowest Population (in %) of Peru?
Make the answer very short. 1.4. What is the difference between the highest and the lowest Population (in %) of Spain?
Your answer should be very brief. 0.58. 